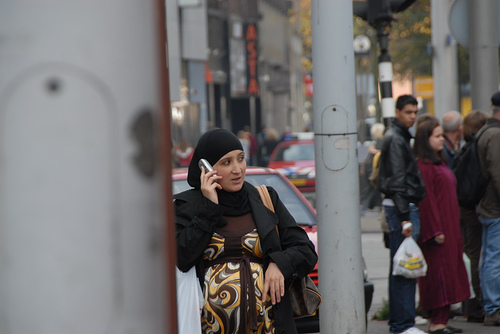<image>What kind of animal do these people spend time with? I am not sure what kind of animal these people spend time with. It could be either cats or dogs. What kind of animal do these people spend time with? I am not sure what kind of animal these people spend time with. It can be cats, dogs or goats. 